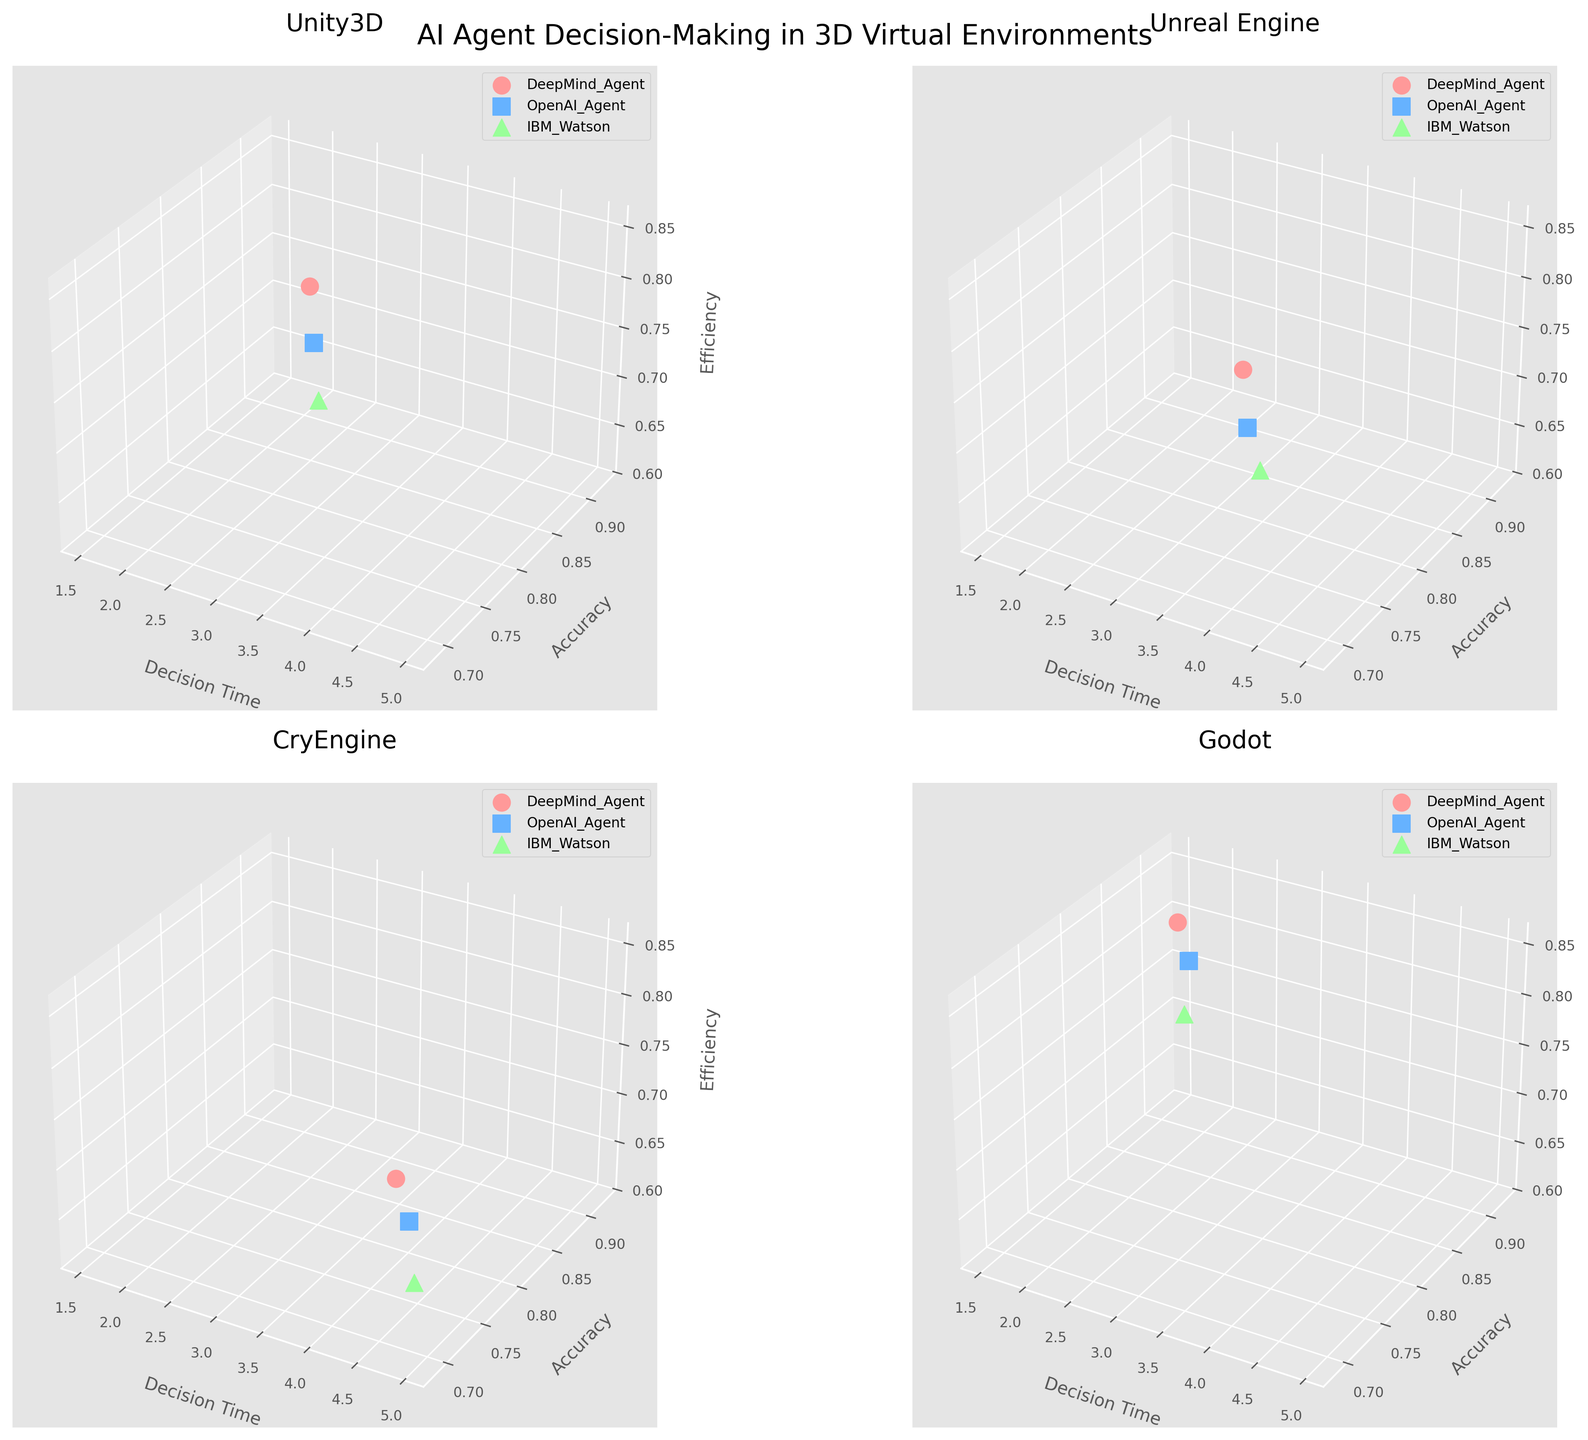What is the title of the overall figure? The title of the overall figure is prominently displayed at the top and describes the main theme of the figure, which is typically found in a large font and centered.
Answer: AI Agent Decision-Making in 3D Virtual Environments Which agent has the highest efficiency score in the Unity3D environment? Locate the subplot titled 'Unity3D', then find the data point for each agent. The 'DeepMind_Agent' has the highest efficiency score, represented by a higher position on the efficiency axis.
Answer: DeepMind Agent What are the axes labels in these plots? Each subplot has three axes, labeled as 'Decision Time' (x-axis), 'Accuracy' (y-axis), and 'Efficiency' (z-axis). These labels are consistent across all subplots.
Answer: Decision Time, Accuracy, Efficiency Considering accuracy and efficiency, which agent performed better in Unreal Engine: DeepMind_Agent or OpenAI_Agent? In the subplot labeled 'Unreal Engine', compare the positions of the 'DeepMind_Agent' and 'OpenAI_Agent' data points. The 'DeepMind_Agent' has higher accuracy and efficiency scores.
Answer: DeepMind Agent Which environment shows the greatest variation in decision time among all agents? Compare the range of decision times in each subplot. The 'CryEngine' subplot shows the widest spread of decision times from approximately 4.1 to 4.7.
Answer: CryEngine How do the efficiency scores of the agents in the Godot environment compare to those in the CryEngine environment? Compare the z-axis positions for agents in the 'Godot' subplot with those in the 'CryEngine' subplot. Agents in the 'Godot' environment generally have higher efficiency scores.
Answer: Higher in Godot What is the accuracy range for the IBM Watson agent across all environments? Identify the IBM Watson data points in all subplots and note the accuracy values. The range is from 0.72 in 'CryEngine' to 0.84 in 'Godot'.
Answer: 0.72 to 0.84 Which agent has the slowest decision time in the Unreal Engine environment? In the 'Unreal Engine' subplot, check the data points along the decision time axis. The 'IBM_Watson' agent has the slowest decision time at 3.8.
Answer: IBM Watson Which environment has the highest complexity level of tasks? Task complexity levels are mentioned in the data and influence the subplot title positioning. The highest complexity level, 5, is for 'CryEngine'.
Answer: CryEngine 